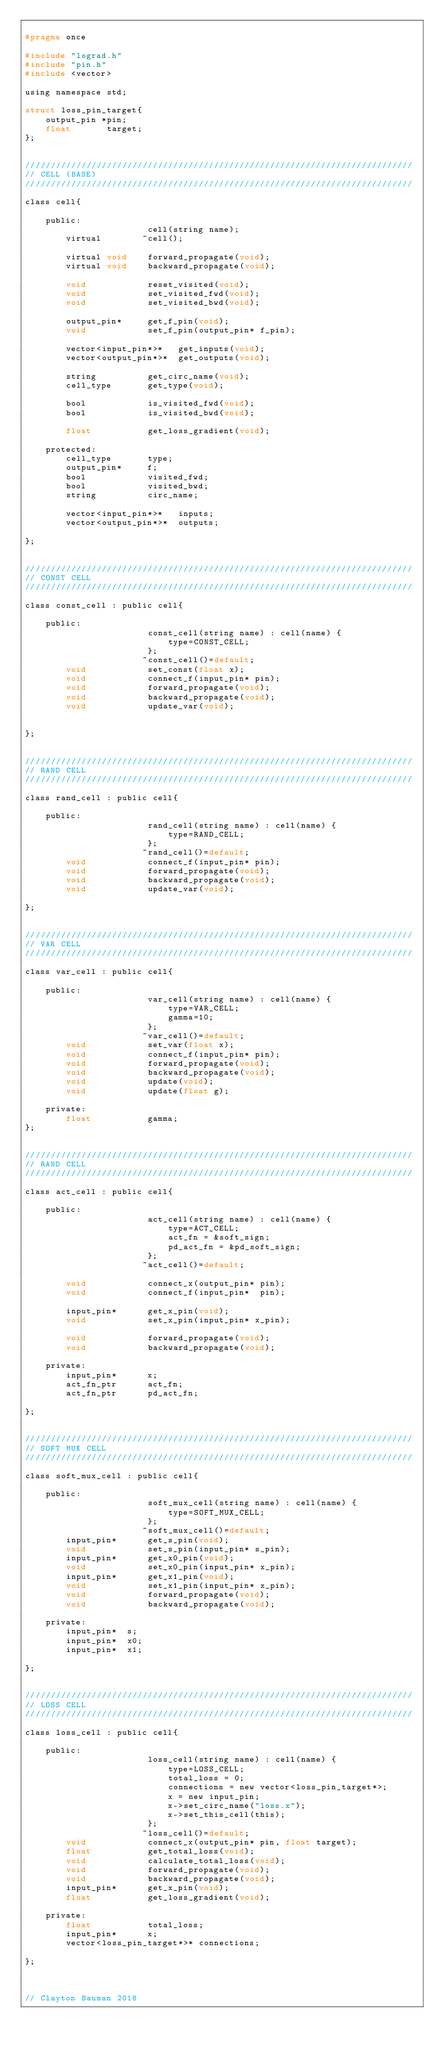Convert code to text. <code><loc_0><loc_0><loc_500><loc_500><_C_>
#pragma once

#include "lograd.h"
#include "pin.h"
#include <vector>

using namespace std;

struct loss_pin_target{
    output_pin *pin;
    float       target;
};


////////////////////////////////////////////////////////////////////////////
// CELL (BASE)
////////////////////////////////////////////////////////////////////////////

class cell{

    public:
                        cell(string name);
        virtual        ~cell();

        virtual void    forward_propagate(void);
        virtual void    backward_propagate(void);

        void            reset_visited(void);
        void            set_visited_fwd(void);
        void            set_visited_bwd(void);

        output_pin*     get_f_pin(void);
        void            set_f_pin(output_pin* f_pin);

        vector<input_pin*>*   get_inputs(void);
        vector<output_pin*>*  get_outputs(void);

        string          get_circ_name(void);
        cell_type       get_type(void);

        bool            is_visited_fwd(void);
        bool            is_visited_bwd(void);

        float           get_loss_gradient(void);

    protected:
        cell_type       type;
        output_pin*     f;
        bool            visited_fwd;
        bool            visited_bwd;
        string          circ_name;

        vector<input_pin*>*   inputs;
        vector<output_pin*>*  outputs;

};


////////////////////////////////////////////////////////////////////////////
// CONST CELL
////////////////////////////////////////////////////////////////////////////

class const_cell : public cell{

    public:
                        const_cell(string name) : cell(name) {
                            type=CONST_CELL;
                        };
                       ~const_cell()=default;
        void            set_const(float x);
        void            connect_f(input_pin* pin);
        void            forward_propagate(void);
        void            backward_propagate(void);
        void            update_var(void);


};


////////////////////////////////////////////////////////////////////////////
// RAND CELL
////////////////////////////////////////////////////////////////////////////

class rand_cell : public cell{

    public:
                        rand_cell(string name) : cell(name) {
                            type=RAND_CELL;
                        };
                       ~rand_cell()=default;
        void            connect_f(input_pin* pin);
        void            forward_propagate(void);
        void            backward_propagate(void);
        void            update_var(void);

};


////////////////////////////////////////////////////////////////////////////
// VAR CELL
////////////////////////////////////////////////////////////////////////////

class var_cell : public cell{

    public:
                        var_cell(string name) : cell(name) {
                            type=VAR_CELL;
                            gamma=10;
                        };
                       ~var_cell()=default;
        void            set_var(float x);
        void            connect_f(input_pin* pin);
        void            forward_propagate(void);
        void            backward_propagate(void);
        void            update(void);
        void            update(float g);

    private:
        float           gamma;
};


////////////////////////////////////////////////////////////////////////////
// RAND CELL
////////////////////////////////////////////////////////////////////////////

class act_cell : public cell{

    public:
                        act_cell(string name) : cell(name) {
                            type=ACT_CELL;
                            act_fn = &soft_sign;
                            pd_act_fn = &pd_soft_sign;
                        };
                       ~act_cell()=default;

        void            connect_x(output_pin* pin);
        void            connect_f(input_pin*  pin);

        input_pin*      get_x_pin(void);
        void            set_x_pin(input_pin* x_pin);

        void            forward_propagate(void);
        void            backward_propagate(void);

    private:
        input_pin*      x;
        act_fn_ptr      act_fn;
        act_fn_ptr      pd_act_fn;

};


////////////////////////////////////////////////////////////////////////////
// SOFT MUX CELL
////////////////////////////////////////////////////////////////////////////

class soft_mux_cell : public cell{

    public:
                        soft_mux_cell(string name) : cell(name) {
                            type=SOFT_MUX_CELL;
                        };
                       ~soft_mux_cell()=default;
        input_pin*      get_s_pin(void);
        void            set_s_pin(input_pin* s_pin);
        input_pin*      get_x0_pin(void);
        void            set_x0_pin(input_pin* x_pin);
        input_pin*      get_x1_pin(void);
        void            set_x1_pin(input_pin* x_pin);
        void            forward_propagate(void);
        void            backward_propagate(void);

    private:
        input_pin*  s;
        input_pin*  x0;
        input_pin*  x1;

};


////////////////////////////////////////////////////////////////////////////
// LOSS CELL
////////////////////////////////////////////////////////////////////////////

class loss_cell : public cell{

    public:
                        loss_cell(string name) : cell(name) {
                            type=LOSS_CELL;
                            total_loss = 0;
                            connections = new vector<loss_pin_target*>;
                            x = new input_pin;
                            x->set_circ_name("loss.x");
                            x->set_this_cell(this);
                        };
                       ~loss_cell()=default;
        void            connect_x(output_pin* pin, float target);
        float           get_total_loss(void);
        void            calculate_total_loss(void);
        void            forward_propagate(void);
        void            backward_propagate(void);
        input_pin*      get_x_pin(void);
        float           get_loss_gradient(void);

    private:
        float           total_loss;
        input_pin*      x;
        vector<loss_pin_target*>* connections;

};



// Clayton Bauman 2018

</code> 